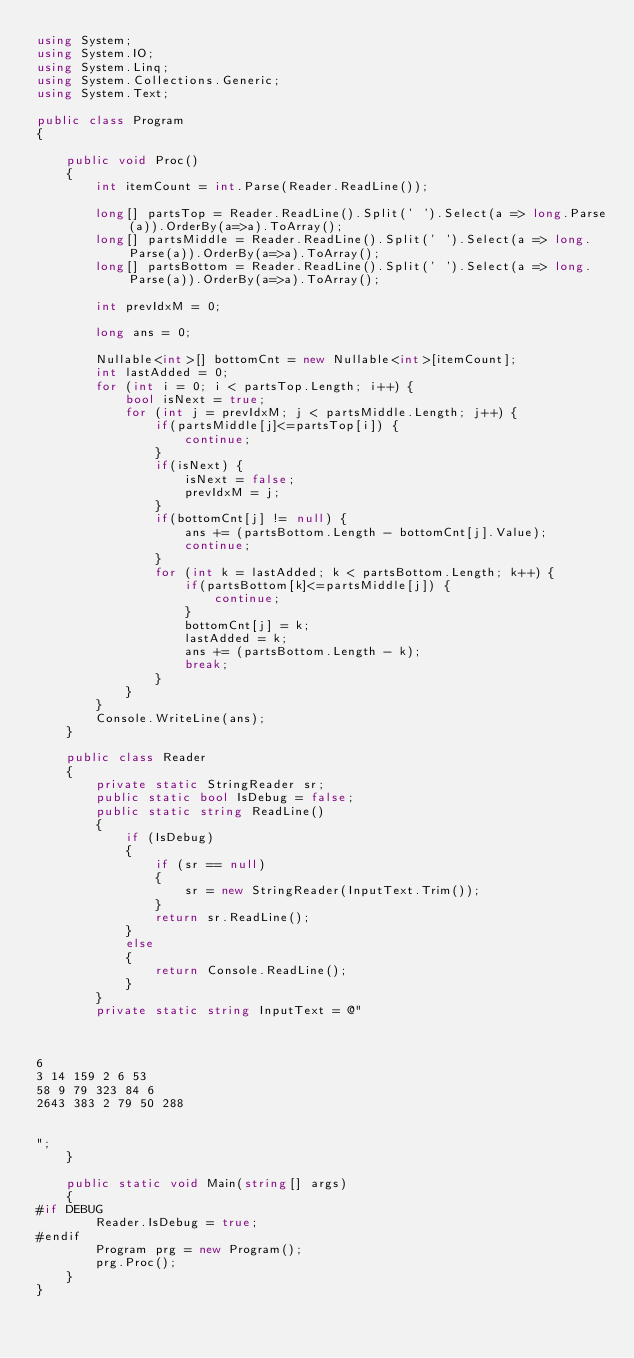<code> <loc_0><loc_0><loc_500><loc_500><_C#_>using System;
using System.IO;
using System.Linq;
using System.Collections.Generic;
using System.Text;

public class Program
{

    public void Proc()
    {
        int itemCount = int.Parse(Reader.ReadLine());

        long[] partsTop = Reader.ReadLine().Split(' ').Select(a => long.Parse(a)).OrderBy(a=>a).ToArray();
        long[] partsMiddle = Reader.ReadLine().Split(' ').Select(a => long.Parse(a)).OrderBy(a=>a).ToArray();
        long[] partsBottom = Reader.ReadLine().Split(' ').Select(a => long.Parse(a)).OrderBy(a=>a).ToArray();

        int prevIdxM = 0;

        long ans = 0;

        Nullable<int>[] bottomCnt = new Nullable<int>[itemCount];
        int lastAdded = 0;
        for (int i = 0; i < partsTop.Length; i++) {
            bool isNext = true;
            for (int j = prevIdxM; j < partsMiddle.Length; j++) {
                if(partsMiddle[j]<=partsTop[i]) {
                    continue;
                }
                if(isNext) {
                    isNext = false;
                    prevIdxM = j;
                }
                if(bottomCnt[j] != null) {
                    ans += (partsBottom.Length - bottomCnt[j].Value);
                    continue;
                }
                for (int k = lastAdded; k < partsBottom.Length; k++) {
                    if(partsBottom[k]<=partsMiddle[j]) {
                        continue;
                    }
                    bottomCnt[j] = k;
                    lastAdded = k;
                    ans += (partsBottom.Length - k);
                    break;
                }
            }
        }
        Console.WriteLine(ans);
    }

    public class Reader
    {
        private static StringReader sr;
        public static bool IsDebug = false;
        public static string ReadLine()
        {
            if (IsDebug)
            {
                if (sr == null)
                {
                    sr = new StringReader(InputText.Trim());
                }
                return sr.ReadLine();
            }
            else
            {
                return Console.ReadLine();
            }
        }
        private static string InputText = @"



6
3 14 159 2 6 53
58 9 79 323 84 6
2643 383 2 79 50 288


";
    }

    public static void Main(string[] args)
    {
#if DEBUG
        Reader.IsDebug = true;
#endif
        Program prg = new Program();
        prg.Proc();
    }
}
</code> 